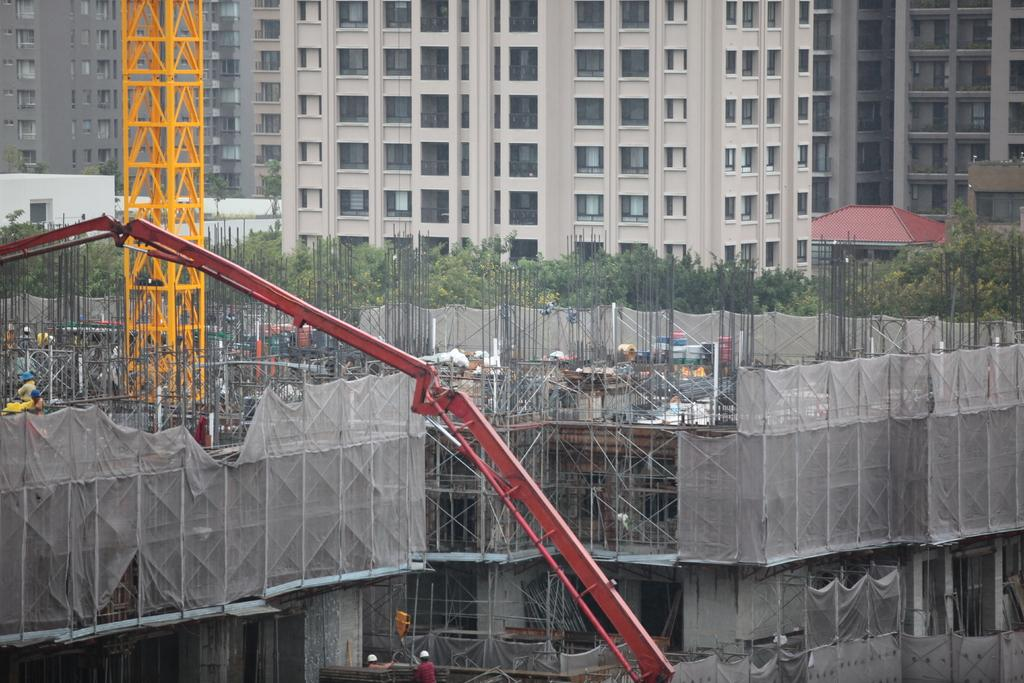What is happening in the image? The image shows the construction of a building. What equipment is being used during the construction? There are cranes in the image, and there are rods visible as well. What safety precautions are being taken by the workers? Some people in the image are wearing helmets. What can be seen in the background of the image? There are trees and buildings with windows visible in the background. What year is the protest taking place in the image? There is no protest present in the image; it shows the construction of a building. What type of camp can be seen in the image? There is no camp present in the image. 